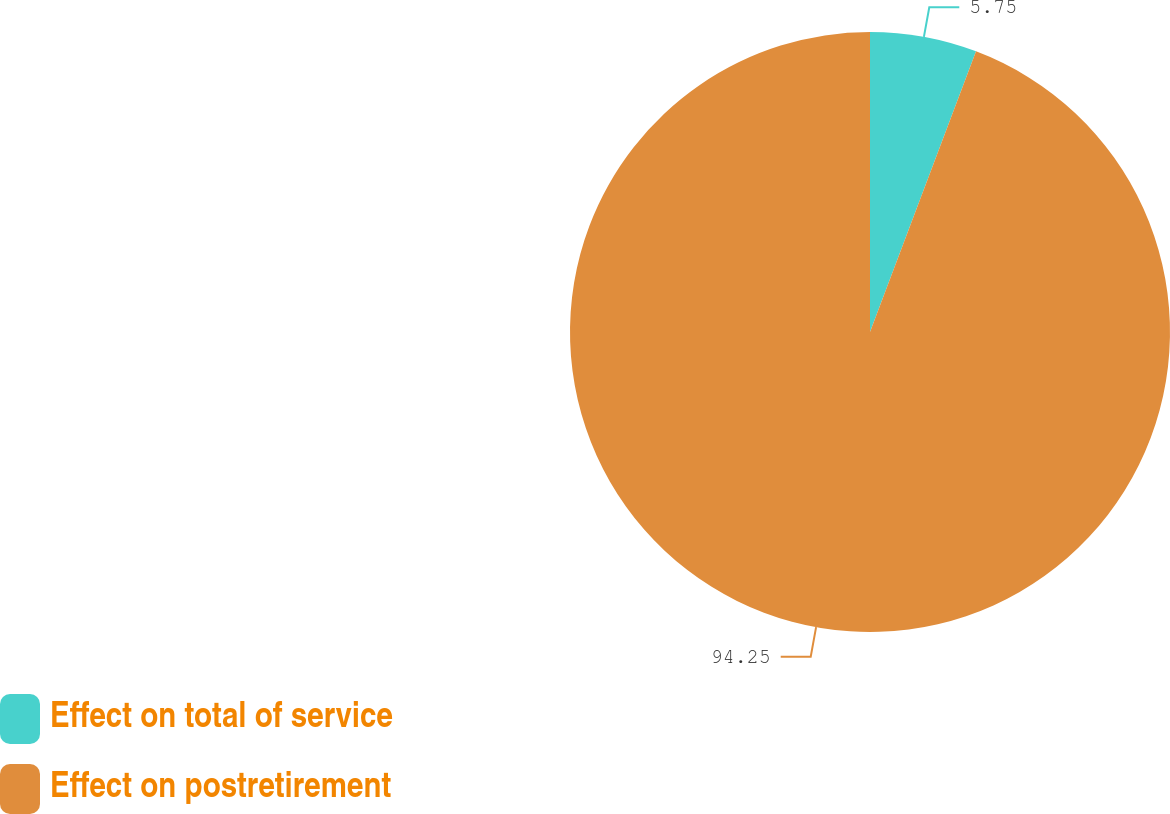Convert chart. <chart><loc_0><loc_0><loc_500><loc_500><pie_chart><fcel>Effect on total of service<fcel>Effect on postretirement<nl><fcel>5.75%<fcel>94.25%<nl></chart> 